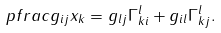<formula> <loc_0><loc_0><loc_500><loc_500>\ p f r a c { g _ { i j } } { x _ { k } } = g _ { l j } \Gamma ^ { l } _ { k i } + g _ { i l } \Gamma ^ { l } _ { k j } .</formula> 